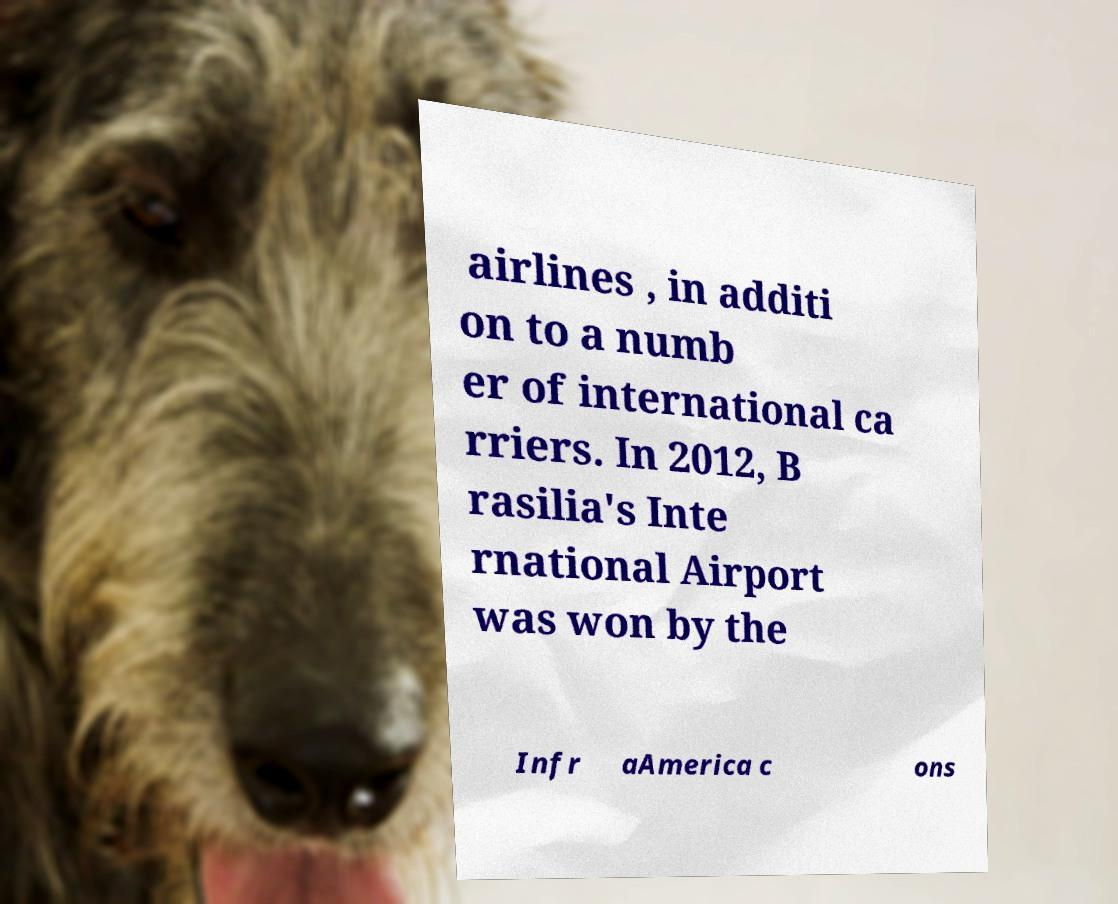Please read and relay the text visible in this image. What does it say? airlines , in additi on to a numb er of international ca rriers. In 2012, B rasilia's Inte rnational Airport was won by the Infr aAmerica c ons 